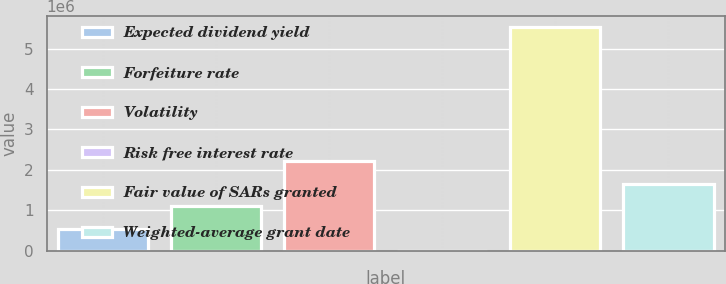<chart> <loc_0><loc_0><loc_500><loc_500><bar_chart><fcel>Expected dividend yield<fcel>Forfeiture rate<fcel>Volatility<fcel>Risk free interest rate<fcel>Fair value of SARs granted<fcel>Weighted-average grant date<nl><fcel>553301<fcel>1.1066e+06<fcel>2.2132e+06<fcel>0.94<fcel>5.533e+06<fcel>1.6599e+06<nl></chart> 